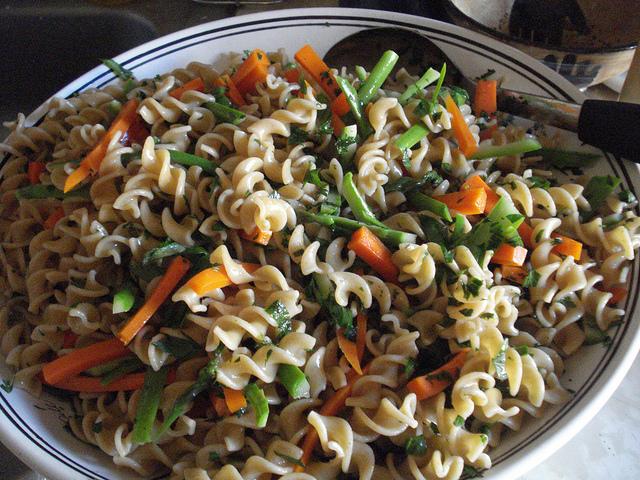What are the orange veggies?
Keep it brief. Carrots. Is the food covered?
Quick response, please. No. Is this a summer salad?
Concise answer only. Yes. Is there meat in this dish?
Answer briefly. No. What is this dish called?
Be succinct. Pasta. What type of dish is this?
Give a very brief answer. Pasta. This dish is made primarily of what food?
Short answer required. Pasta. 